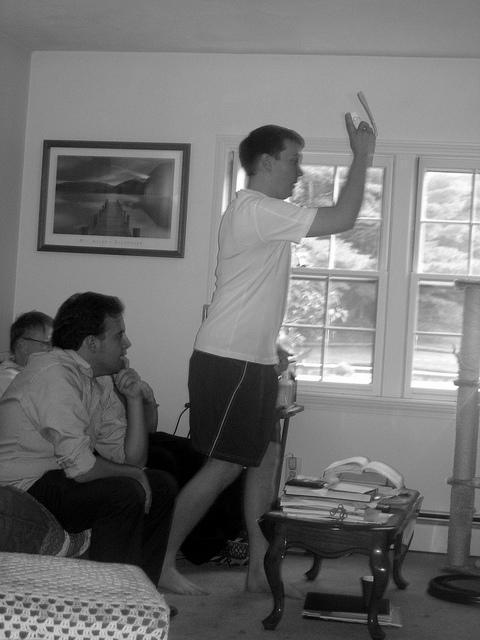How many windows are in the picture?
Give a very brief answer. 2. How many people are playing a video game?
Give a very brief answer. 3. How many people can you see?
Give a very brief answer. 3. How many couches are in the photo?
Give a very brief answer. 3. 